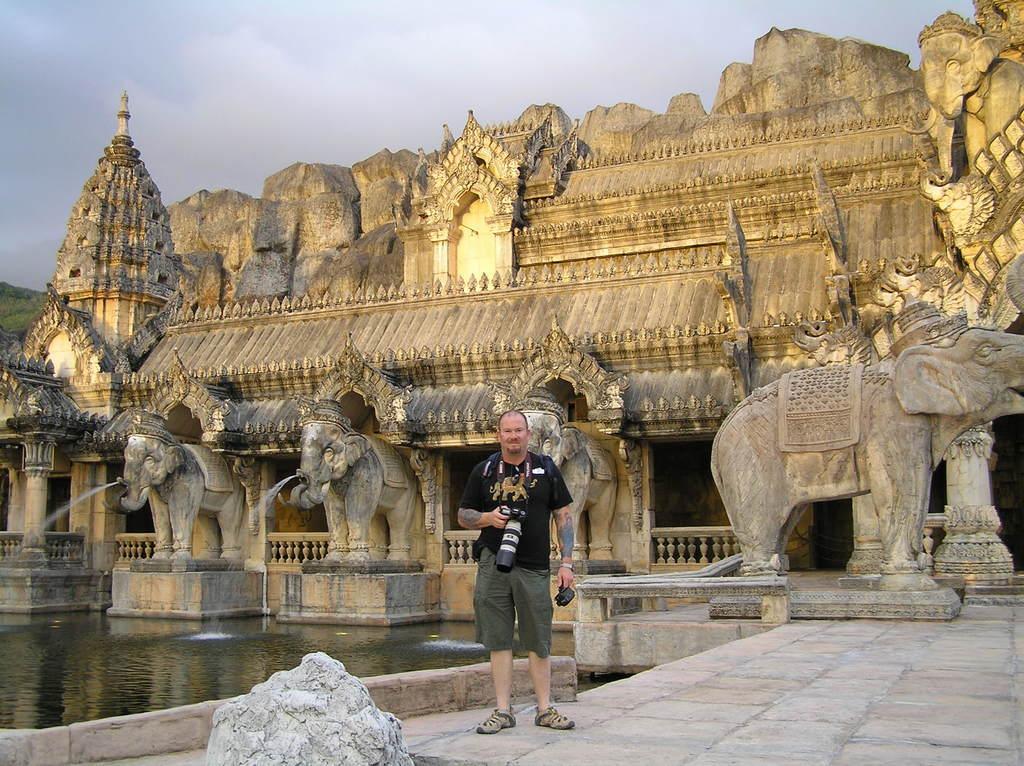In one or two sentences, can you explain what this image depicts? This image consists of a man wearing a black T-shirt and holding a camera. At the bottom, there is a floor along and we can see a rock. In the background, there are sculptures. And we can see the elephants. On the left, there is water. At the top, there is sky. 